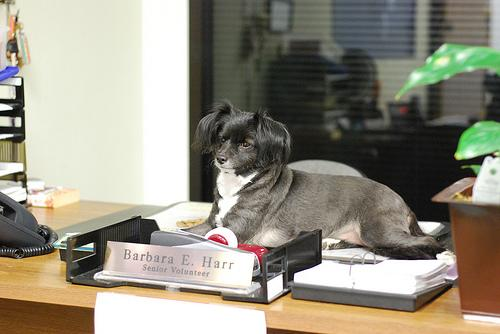Provide a brief description of the central theme present in the image. A brown and white dog is situated on an office desk along with various objects. What is the key figure in the image and what is its activity? A dog is laying on the desk with white and gray fur. Identify the main character in the illustration and describe what they are occupied with. A dog with a combination of brown and white fur is resting on a wooden desk surrounded by assorted items. Summarize the primary subject and their current situation in the image. A dog with gray and white fur is relaxed on a cluttered desk. Mention the prominent object and their action in the image. A gray and white dog is lying on a desk that has multiple items on it. Give a concise description of the chief entity and the ongoing action in the picture. A white and gray dog lies on a desk filled with various objects like a black phone, red tape holder, and green plant. Point out the central figure in the image and describe their ongoing activity. A dog with white and gray hairs is comfortably laying on a desk that has many items, such as a phone, plant, and tape holder. Elucidate the primary subject and the happening in the image. A dog of white and gray colors is at ease on an office desk with different accessories on it. Explain the core focus and its current status in the image. A dog with a mix of white and gray hairs is unwinding on a wooden desk surrounded by an array of items. Tell the main object and the event occurring in the image briefly. A dog featuring white and gray fur takes a break on a messy desk with several objects. 